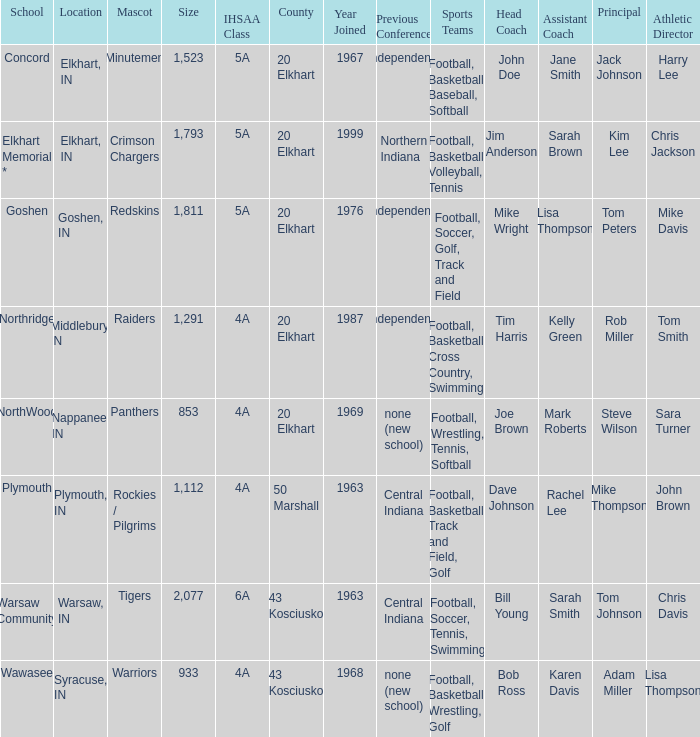What is the size of the team that was previously from Central Indiana conference, and is in IHSSA Class 4a? 1112.0. 